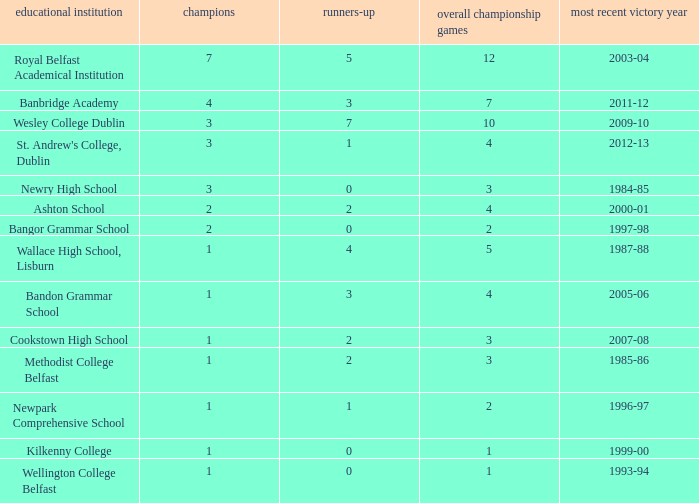What are the names that had a finalist score of 2? Ashton School, Cookstown High School, Methodist College Belfast. 